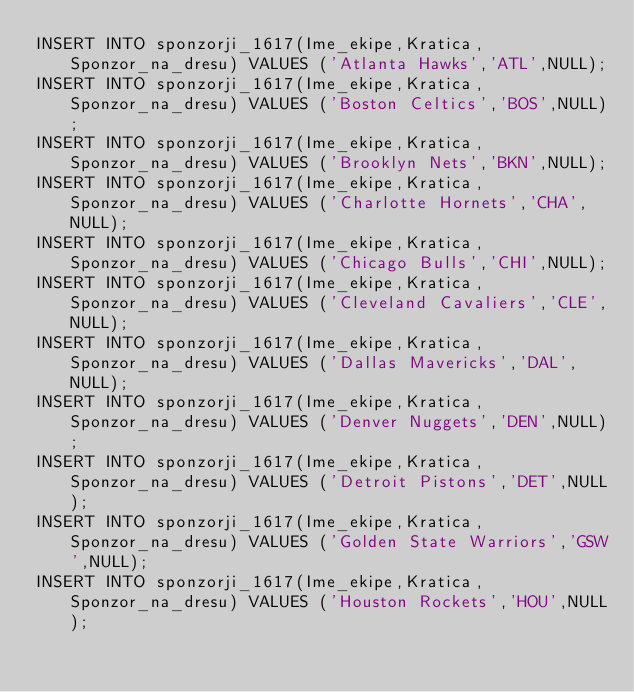Convert code to text. <code><loc_0><loc_0><loc_500><loc_500><_SQL_>INSERT INTO sponzorji_1617(Ime_ekipe,Kratica,Sponzor_na_dresu) VALUES ('Atlanta Hawks','ATL',NULL);
INSERT INTO sponzorji_1617(Ime_ekipe,Kratica,Sponzor_na_dresu) VALUES ('Boston Celtics','BOS',NULL);
INSERT INTO sponzorji_1617(Ime_ekipe,Kratica,Sponzor_na_dresu) VALUES ('Brooklyn Nets','BKN',NULL);
INSERT INTO sponzorji_1617(Ime_ekipe,Kratica,Sponzor_na_dresu) VALUES ('Charlotte Hornets','CHA',NULL);
INSERT INTO sponzorji_1617(Ime_ekipe,Kratica,Sponzor_na_dresu) VALUES ('Chicago Bulls','CHI',NULL);
INSERT INTO sponzorji_1617(Ime_ekipe,Kratica,Sponzor_na_dresu) VALUES ('Cleveland Cavaliers','CLE',NULL);
INSERT INTO sponzorji_1617(Ime_ekipe,Kratica,Sponzor_na_dresu) VALUES ('Dallas Mavericks','DAL',NULL);
INSERT INTO sponzorji_1617(Ime_ekipe,Kratica,Sponzor_na_dresu) VALUES ('Denver Nuggets','DEN',NULL);
INSERT INTO sponzorji_1617(Ime_ekipe,Kratica,Sponzor_na_dresu) VALUES ('Detroit Pistons','DET',NULL);
INSERT INTO sponzorji_1617(Ime_ekipe,Kratica,Sponzor_na_dresu) VALUES ('Golden State Warriors','GSW',NULL);
INSERT INTO sponzorji_1617(Ime_ekipe,Kratica,Sponzor_na_dresu) VALUES ('Houston Rockets','HOU',NULL);</code> 